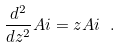Convert formula to latex. <formula><loc_0><loc_0><loc_500><loc_500>\frac { d ^ { 2 } } { d z ^ { 2 } } A i = z A i \ .</formula> 